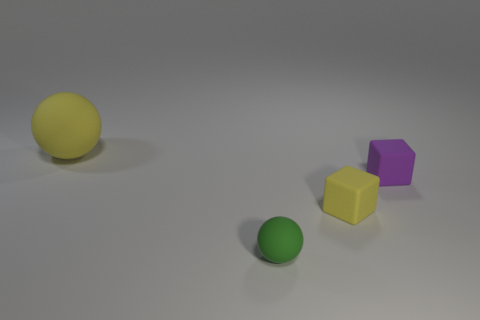What color is the other small matte object that is the same shape as the purple thing?
Your response must be concise. Yellow. Does the yellow cube have the same size as the green rubber ball?
Ensure brevity in your answer.  Yes. Is the number of big rubber objects that are to the left of the tiny purple rubber block the same as the number of big yellow balls that are on the left side of the big matte ball?
Provide a short and direct response. No. Is there a big matte object?
Your answer should be very brief. Yes. The yellow object that is the same shape as the small purple thing is what size?
Offer a very short reply. Small. What size is the rubber object that is to the right of the yellow cube?
Offer a very short reply. Small. Is the number of purple rubber blocks right of the large sphere greater than the number of large purple cylinders?
Your answer should be compact. Yes. What shape is the small green rubber thing?
Ensure brevity in your answer.  Sphere. There is a rubber ball that is in front of the large matte ball; is it the same color as the object that is left of the tiny green sphere?
Give a very brief answer. No. Does the small green rubber thing have the same shape as the tiny yellow thing?
Provide a succinct answer. No. 